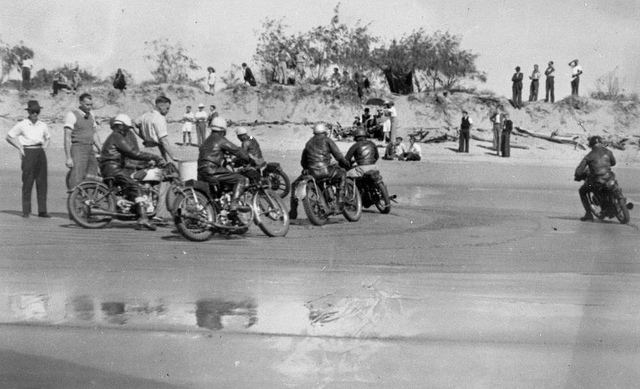Explain the visual content of the image in great detail. The image depicts a vintage scene featuring eight individuals, all of whom appear to be engaged in a motorcycle race on a beach. Most of the individuals are sitting on their motorcycles, which are arranged in a staggered line, indicating the start or a pause in the race. The racers are dressed in leather jackets and helmets, which suggests that this is a formal or organized racing event. In the background, there are spectators, some standing and some sitting on the sandy dunes, watching the race unfold. The scene gives a historical feel, likely set in the early to mid-20th century, given the style of the motorcycles and clothing. 